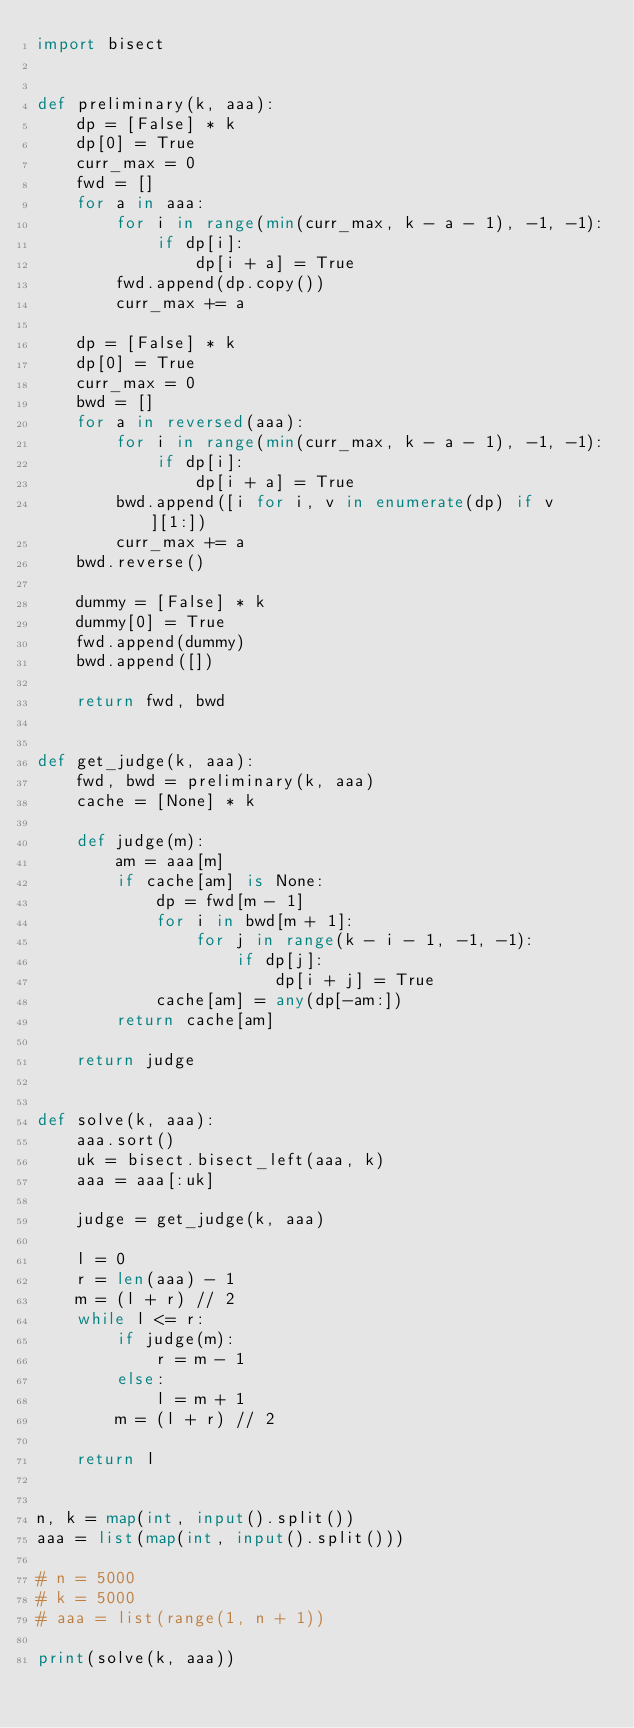<code> <loc_0><loc_0><loc_500><loc_500><_Python_>import bisect


def preliminary(k, aaa):
    dp = [False] * k
    dp[0] = True
    curr_max = 0
    fwd = []
    for a in aaa:
        for i in range(min(curr_max, k - a - 1), -1, -1):
            if dp[i]:
                dp[i + a] = True
        fwd.append(dp.copy())
        curr_max += a

    dp = [False] * k
    dp[0] = True
    curr_max = 0
    bwd = []
    for a in reversed(aaa):
        for i in range(min(curr_max, k - a - 1), -1, -1):
            if dp[i]:
                dp[i + a] = True
        bwd.append([i for i, v in enumerate(dp) if v][1:])
        curr_max += a
    bwd.reverse()

    dummy = [False] * k
    dummy[0] = True
    fwd.append(dummy)
    bwd.append([])

    return fwd, bwd


def get_judge(k, aaa):
    fwd, bwd = preliminary(k, aaa)
    cache = [None] * k

    def judge(m):
        am = aaa[m]
        if cache[am] is None:
            dp = fwd[m - 1]
            for i in bwd[m + 1]:
                for j in range(k - i - 1, -1, -1):
                    if dp[j]:
                        dp[i + j] = True
            cache[am] = any(dp[-am:])
        return cache[am]

    return judge


def solve(k, aaa):
    aaa.sort()
    uk = bisect.bisect_left(aaa, k)
    aaa = aaa[:uk]

    judge = get_judge(k, aaa)

    l = 0
    r = len(aaa) - 1
    m = (l + r) // 2
    while l <= r:
        if judge(m):
            r = m - 1
        else:
            l = m + 1
        m = (l + r) // 2

    return l


n, k = map(int, input().split())
aaa = list(map(int, input().split()))

# n = 5000
# k = 5000
# aaa = list(range(1, n + 1))

print(solve(k, aaa))
</code> 